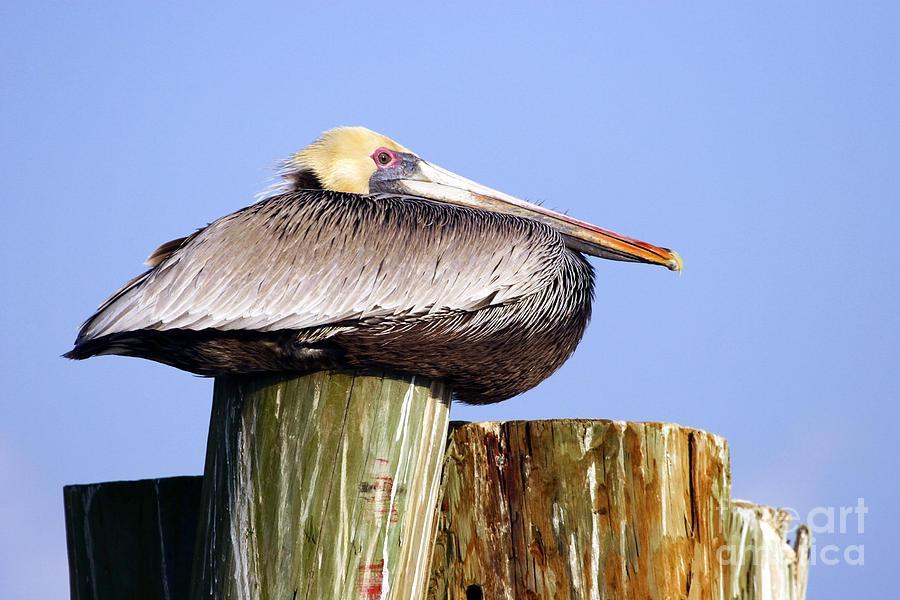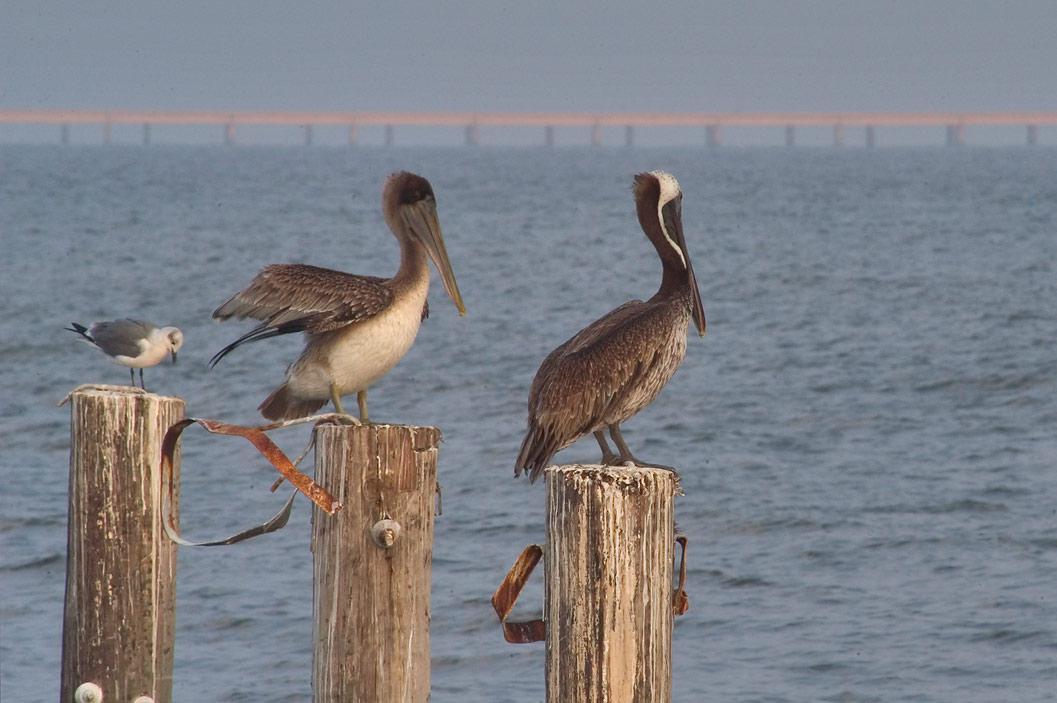The first image is the image on the left, the second image is the image on the right. For the images displayed, is the sentence "Each image shows one pelican perched on a post, and at least one of the birds depicted is facing rightward." factually correct? Answer yes or no. No. The first image is the image on the left, the second image is the image on the right. Given the left and right images, does the statement "In the left image, a pelican is facing right and sitting with its neck buried in its body." hold true? Answer yes or no. Yes. 